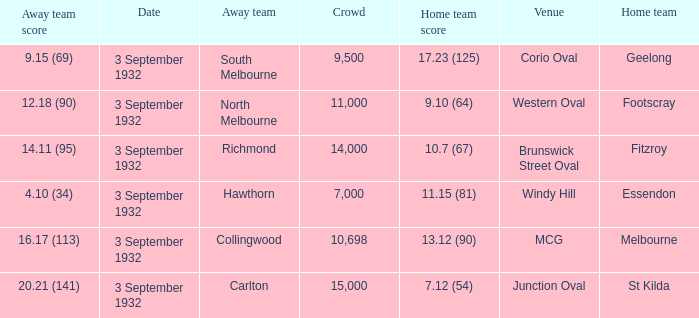What is the name of the Venue for the team that has an Away team score of 14.11 (95)? Brunswick Street Oval. 